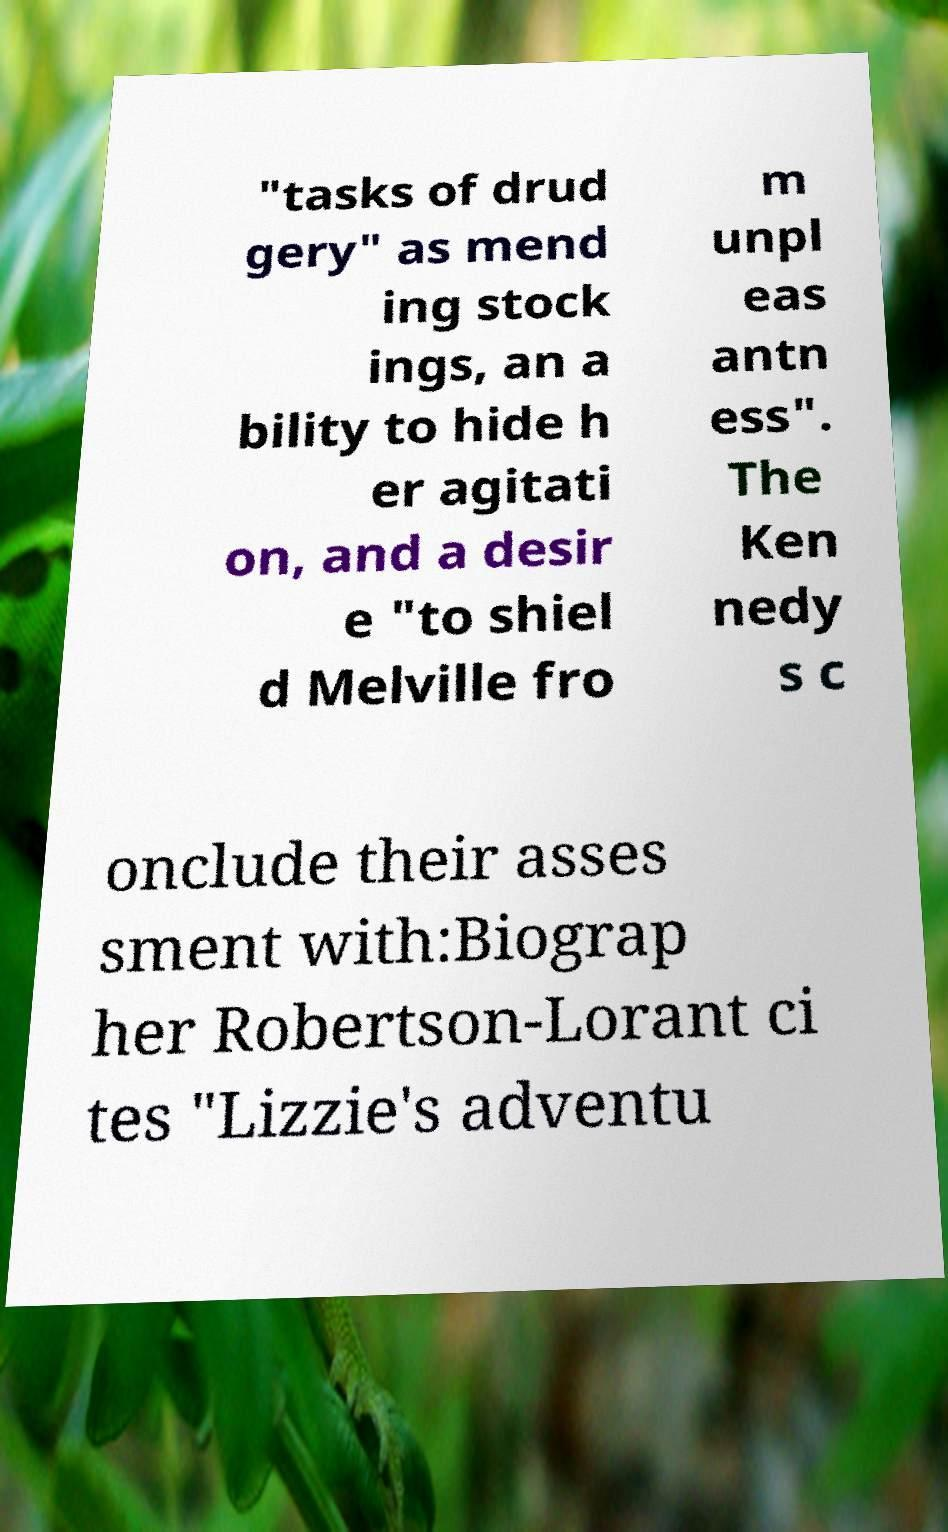I need the written content from this picture converted into text. Can you do that? "tasks of drud gery" as mend ing stock ings, an a bility to hide h er agitati on, and a desir e "to shiel d Melville fro m unpl eas antn ess". The Ken nedy s c onclude their asses sment with:Biograp her Robertson-Lorant ci tes "Lizzie's adventu 